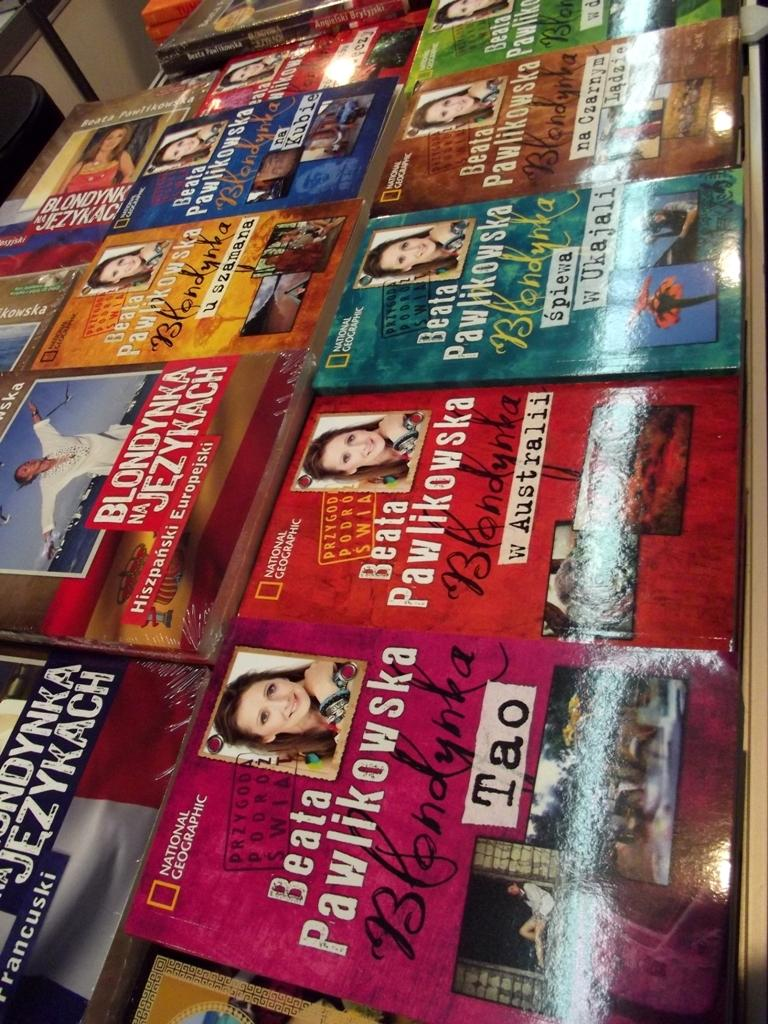<image>
Render a clear and concise summary of the photo. Copies of National Geographic books lined up on a table 